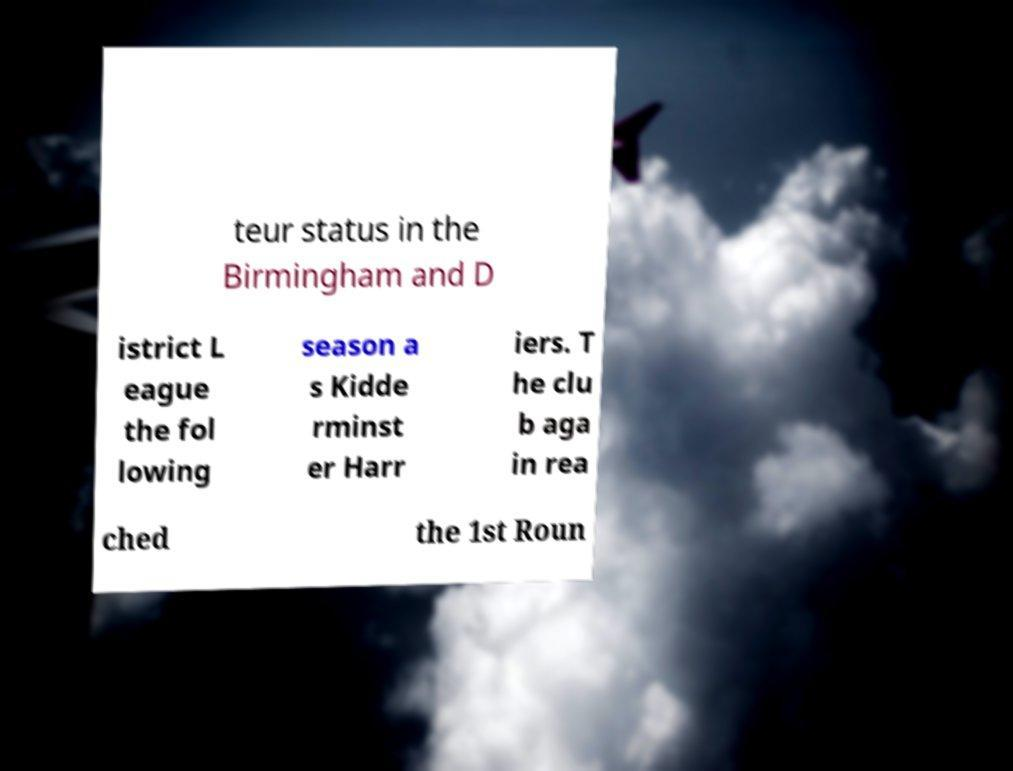What messages or text are displayed in this image? I need them in a readable, typed format. teur status in the Birmingham and D istrict L eague the fol lowing season a s Kidde rminst er Harr iers. T he clu b aga in rea ched the 1st Roun 